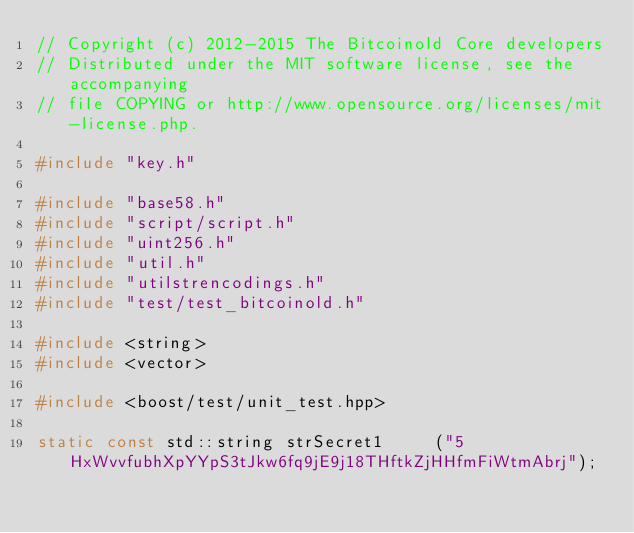Convert code to text. <code><loc_0><loc_0><loc_500><loc_500><_C++_>// Copyright (c) 2012-2015 The Bitcoinold Core developers
// Distributed under the MIT software license, see the accompanying
// file COPYING or http://www.opensource.org/licenses/mit-license.php.

#include "key.h"

#include "base58.h"
#include "script/script.h"
#include "uint256.h"
#include "util.h"
#include "utilstrencodings.h"
#include "test/test_bitcoinold.h"

#include <string>
#include <vector>

#include <boost/test/unit_test.hpp>

static const std::string strSecret1     ("5HxWvvfubhXpYYpS3tJkw6fq9jE9j18THftkZjHHfmFiWtmAbrj");</code> 